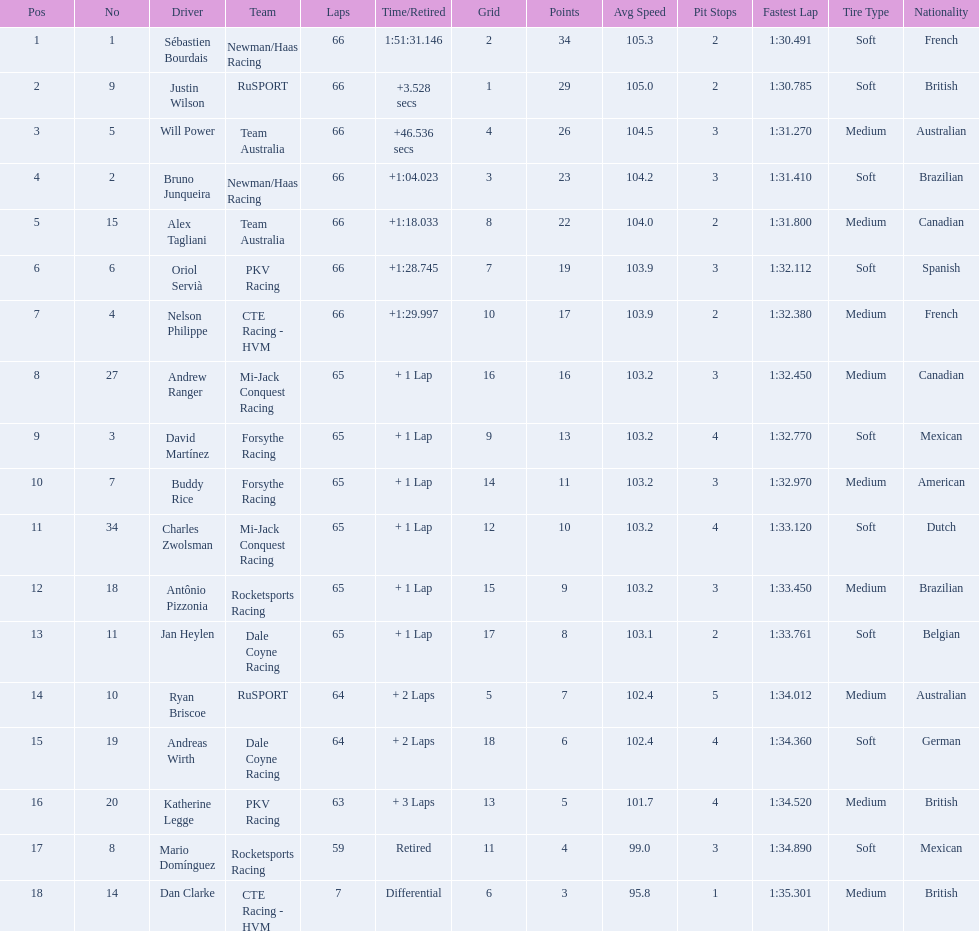How many points did first place receive? 34. How many did last place receive? 3. Who was the recipient of these last place points? Dan Clarke. Would you mind parsing the complete table? {'header': ['Pos', 'No', 'Driver', 'Team', 'Laps', 'Time/Retired', 'Grid', 'Points', 'Avg Speed', 'Pit Stops', 'Fastest Lap', 'Tire Type', 'Nationality'], 'rows': [['1', '1', 'Sébastien Bourdais', 'Newman/Haas Racing', '66', '1:51:31.146', '2', '34', '105.3', '2', '1:30.491', 'Soft', 'French'], ['2', '9', 'Justin Wilson', 'RuSPORT', '66', '+3.528 secs', '1', '29', '105.0', '2', '1:30.785', 'Soft', 'British'], ['3', '5', 'Will Power', 'Team Australia', '66', '+46.536 secs', '4', '26', '104.5', '3', '1:31.270', 'Medium', 'Australian'], ['4', '2', 'Bruno Junqueira', 'Newman/Haas Racing', '66', '+1:04.023', '3', '23', '104.2', '3', '1:31.410', 'Soft', 'Brazilian'], ['5', '15', 'Alex Tagliani', 'Team Australia', '66', '+1:18.033', '8', '22', '104.0', '2', '1:31.800', 'Medium', 'Canadian'], ['6', '6', 'Oriol Servià', 'PKV Racing', '66', '+1:28.745', '7', '19', '103.9', '3', '1:32.112', 'Soft', 'Spanish'], ['7', '4', 'Nelson Philippe', 'CTE Racing - HVM', '66', '+1:29.997', '10', '17', '103.9', '2', '1:32.380', 'Medium', 'French'], ['8', '27', 'Andrew Ranger', 'Mi-Jack Conquest Racing', '65', '+ 1 Lap', '16', '16', '103.2', '3', '1:32.450', 'Medium', 'Canadian'], ['9', '3', 'David Martínez', 'Forsythe Racing', '65', '+ 1 Lap', '9', '13', '103.2', '4', '1:32.770', 'Soft', 'Mexican'], ['10', '7', 'Buddy Rice', 'Forsythe Racing', '65', '+ 1 Lap', '14', '11', '103.2', '3', '1:32.970', 'Medium', 'American'], ['11', '34', 'Charles Zwolsman', 'Mi-Jack Conquest Racing', '65', '+ 1 Lap', '12', '10', '103.2', '4', '1:33.120', 'Soft', 'Dutch'], ['12', '18', 'Antônio Pizzonia', 'Rocketsports Racing', '65', '+ 1 Lap', '15', '9', '103.2', '3', '1:33.450', 'Medium', 'Brazilian'], ['13', '11', 'Jan Heylen', 'Dale Coyne Racing', '65', '+ 1 Lap', '17', '8', '103.1', '2', '1:33.761', 'Soft', 'Belgian'], ['14', '10', 'Ryan Briscoe', 'RuSPORT', '64', '+ 2 Laps', '5', '7', '102.4', '5', '1:34.012', 'Medium', 'Australian'], ['15', '19', 'Andreas Wirth', 'Dale Coyne Racing', '64', '+ 2 Laps', '18', '6', '102.4', '4', '1:34.360', 'Soft', 'German'], ['16', '20', 'Katherine Legge', 'PKV Racing', '63', '+ 3 Laps', '13', '5', '101.7', '4', '1:34.520', 'Medium', 'British'], ['17', '8', 'Mario Domínguez', 'Rocketsports Racing', '59', 'Retired', '11', '4', '99.0', '3', '1:34.890', 'Soft', 'Mexican'], ['18', '14', 'Dan Clarke', 'CTE Racing - HVM', '7', 'Differential', '6', '3', '95.8', '1', '1:35.301', 'Medium', 'British']]} 